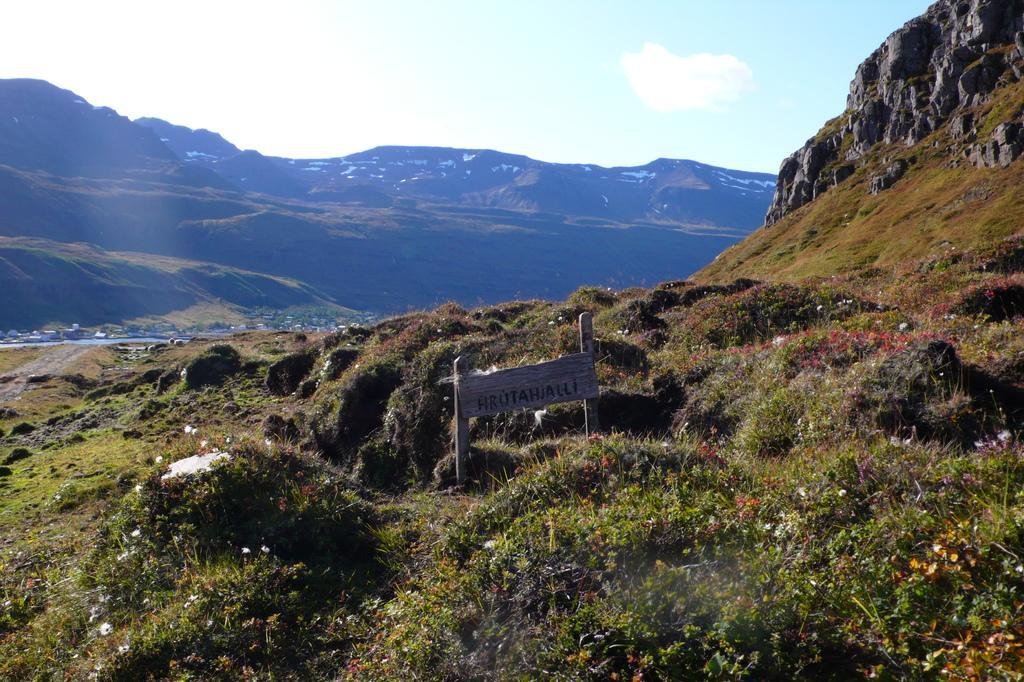How would you summarize this image in a sentence or two? In this image there is a name board , plants with flowers, hills, trees, and in the background there is sky. 